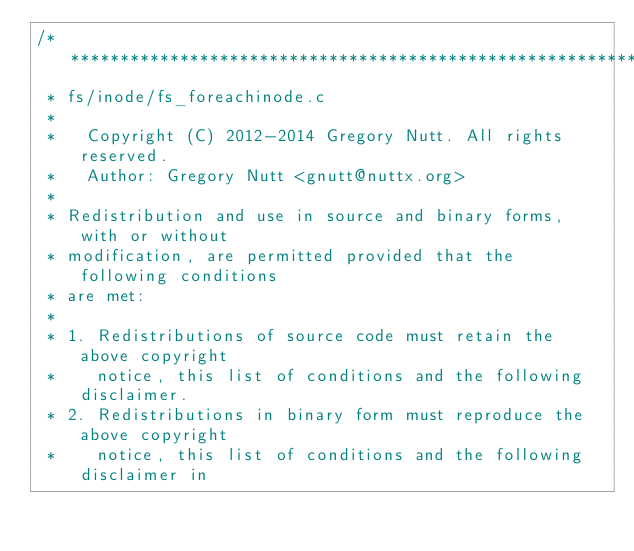Convert code to text. <code><loc_0><loc_0><loc_500><loc_500><_C_>/****************************************************************************
 * fs/inode/fs_foreachinode.c
 *
 *   Copyright (C) 2012-2014 Gregory Nutt. All rights reserved.
 *   Author: Gregory Nutt <gnutt@nuttx.org>
 *
 * Redistribution and use in source and binary forms, with or without
 * modification, are permitted provided that the following conditions
 * are met:
 *
 * 1. Redistributions of source code must retain the above copyright
 *    notice, this list of conditions and the following disclaimer.
 * 2. Redistributions in binary form must reproduce the above copyright
 *    notice, this list of conditions and the following disclaimer in</code> 